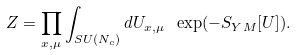Convert formula to latex. <formula><loc_0><loc_0><loc_500><loc_500>Z = \prod _ { x , \mu } \int _ { S U ( N _ { c } ) } d U _ { x , \mu } \ \exp ( - S _ { Y M } [ U ] ) .</formula> 